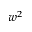Convert formula to latex. <formula><loc_0><loc_0><loc_500><loc_500>w ^ { 2 }</formula> 